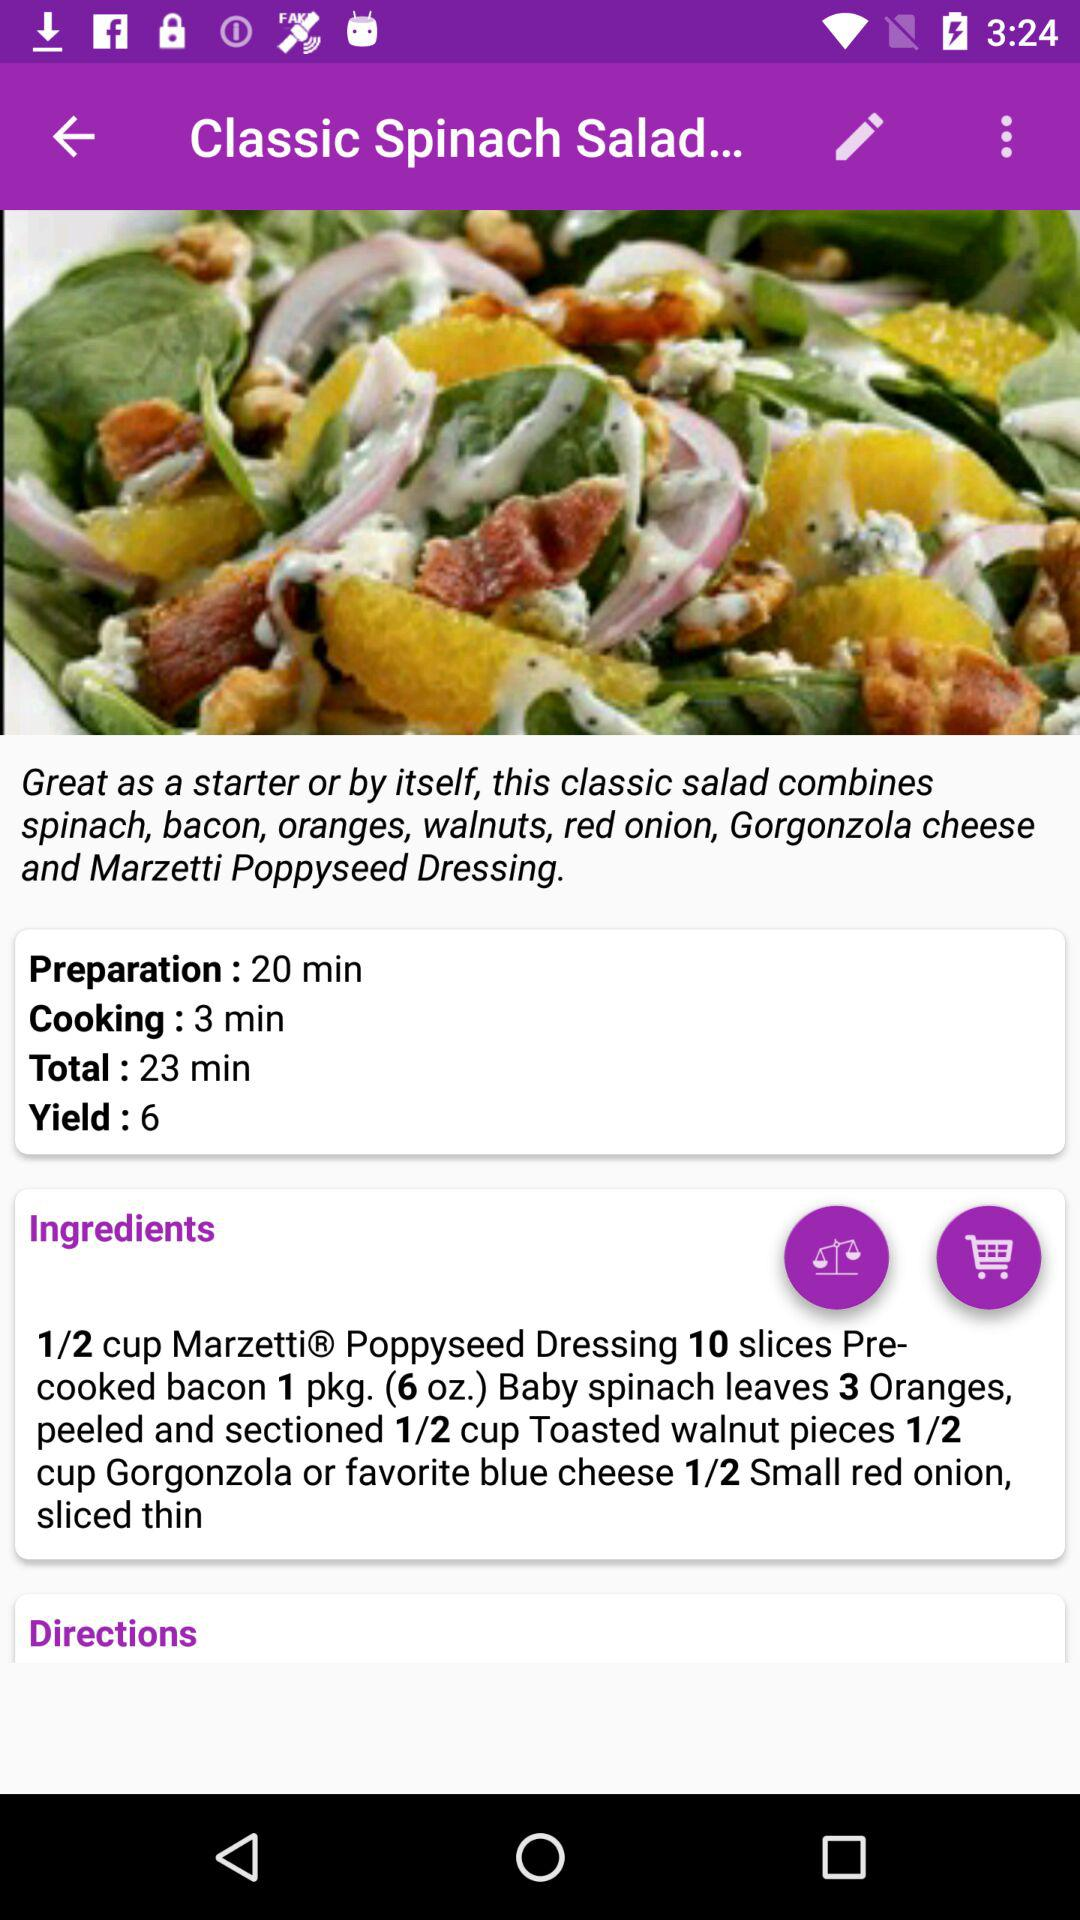What is the preparation time of the dish? The preparation time is 20 minutes. 